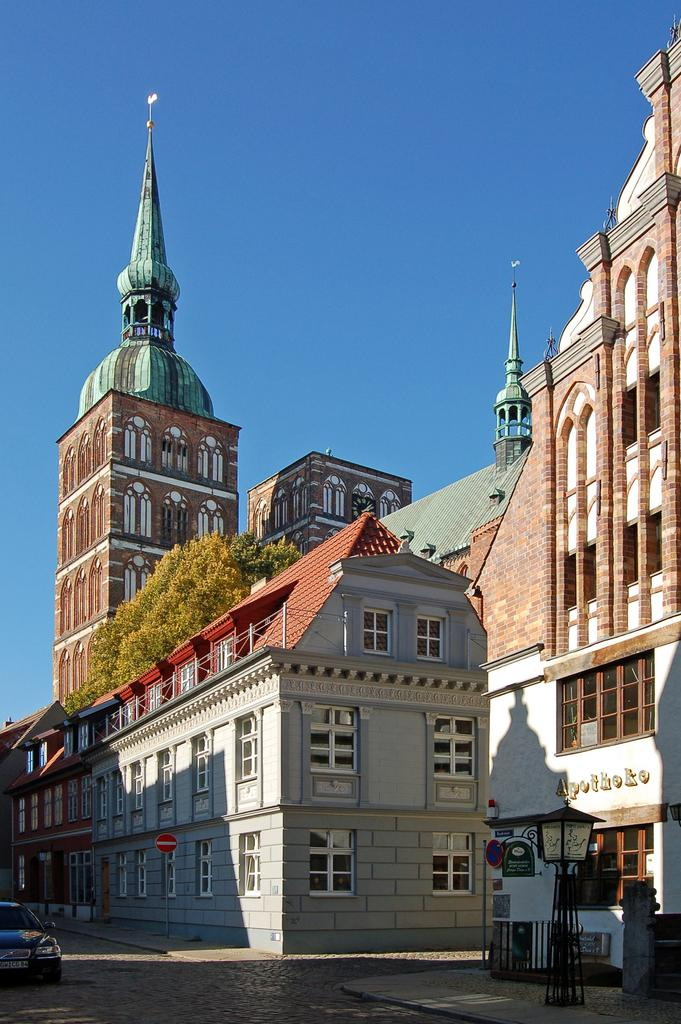What type of structures can be seen in the image? There are buildings in the image. What other natural or man-made elements are present in the image? There are trees, street poles, street lights, and a name board visible in the image. What mode of transportation can be seen on the road in the image? A motor vehicle is on the road in the image. What is visible in the sky in the image? The sky is visible in the image. the image. Can you see any fish swimming in the sky in the image? No, there are no fish present in the image, and the sky is visible, not filled with water for fish to swim in. 